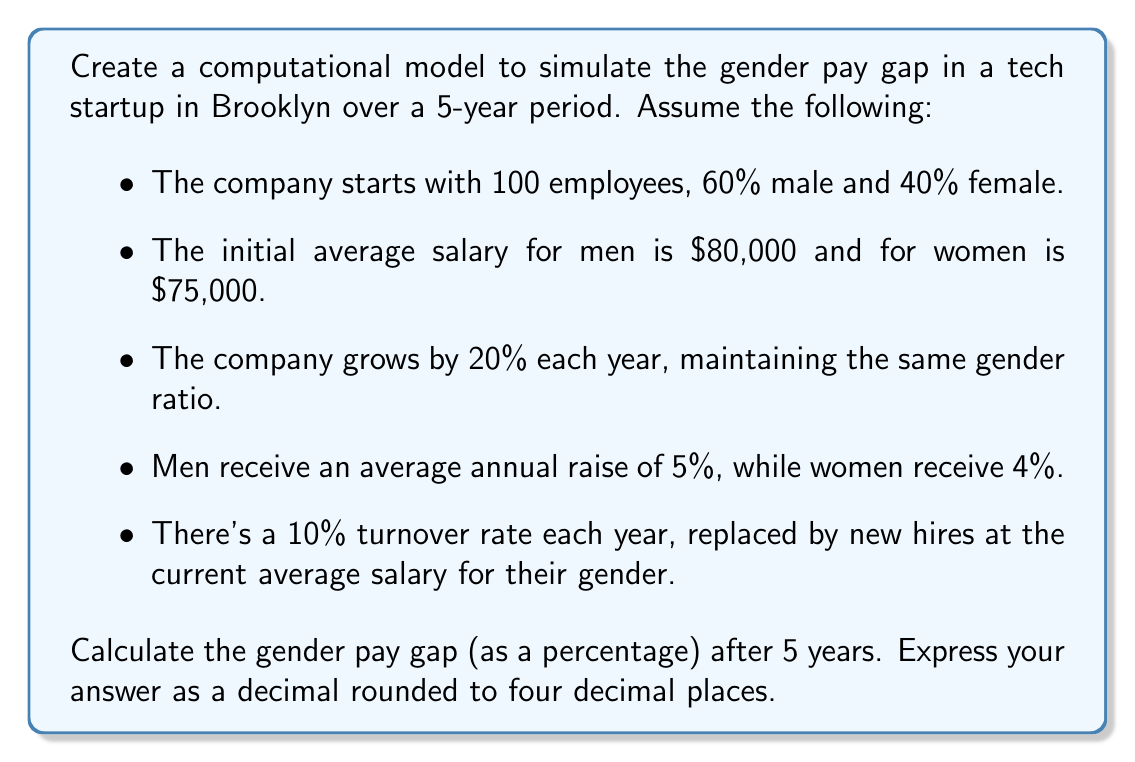Could you help me with this problem? To solve this problem, we'll create a computational model using the given parameters and simulate the changes over 5 years. Let's break it down step by step:

1. Initialize the model:
   - Male employees: $60$
   - Female employees: $40$
   - Male average salary: $\$80,000$
   - Female average salary: $\$75,000$

2. For each year (1 to 5):
   a) Apply growth:
      - New male employees: $60 \times 0.2 = 12$
      - New female employees: $40 \times 0.2 = 8$
   
   b) Apply raises:
      - New male average salary: $\$80,000 \times 1.05 = \$84,000$
      - New female average salary: $\$75,000 \times 1.04 = \$78,000$
   
   c) Apply turnover:
      - Employees leaving (10%):
        Male: $7.2$ (rounded to 7)
        Female: $4.8$ (rounded to 5)
      - Replace with new hires at current average salary

3. Calculate the gender pay gap after 5 years:
   Gender Pay Gap = $\frac{\text{Male Avg Salary} - \text{Female Avg Salary}}{\text{Male Avg Salary}}$

Let's simulate this in a table:

Year | Male Emp | Female Emp | Male Avg Salary | Female Avg Salary
-----|----------|------------|-----------------|-------------------
0    | 60       | 40         | $80,000         | $75,000
1    | 72       | 48         | $84,000         | $78,000
2    | 86       | 58         | $88,200         | $81,120
3    | 103      | 70         | $92,610         | $84,365
4    | 124      | 84         | $97,241         | $87,739
5    | 149      | 101        | $102,103        | $91,249

After 5 years:
Male Average Salary: $\$102,103$
Female Average Salary: $\$91,249$

Gender Pay Gap = $\frac{102,103 - 91,249}{102,103} = 0.10630$ or 10.63%
Answer: 0.1063 